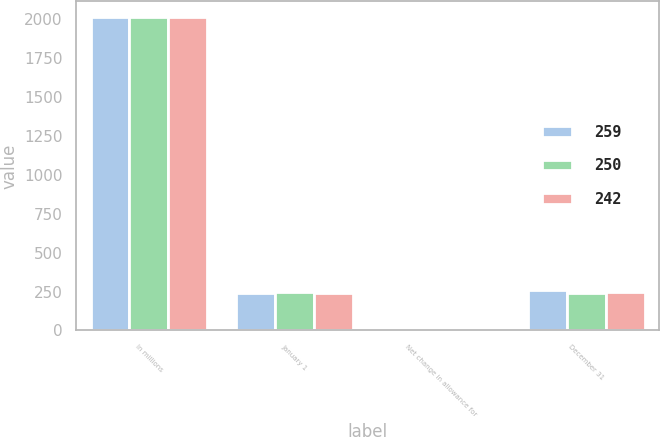Convert chart to OTSL. <chart><loc_0><loc_0><loc_500><loc_500><stacked_bar_chart><ecel><fcel>In millions<fcel>January 1<fcel>Net change in allowance for<fcel>December 31<nl><fcel>259<fcel>2014<fcel>242<fcel>17<fcel>259<nl><fcel>250<fcel>2013<fcel>250<fcel>8<fcel>242<nl><fcel>242<fcel>2012<fcel>240<fcel>10<fcel>250<nl></chart> 